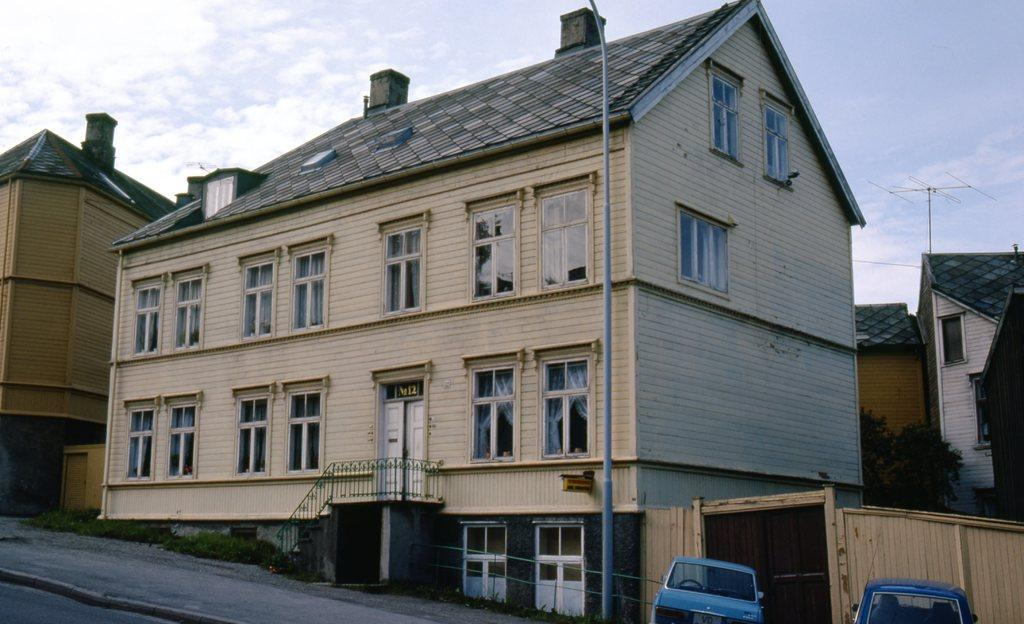What type of structures can be seen in the image? There are buildings in the image. What feature can be found on the buildings or nearby? Railings are present in the image. What type of vegetation is visible in the image? Shrubs and trees are present in the image. What mode of transportation can be seen on the road in the image? Motor vehicles are on the road in the image. What type of communication device is present in the image? There is an antenna in the image. What type of street furniture is visible in the image? A street pole is visible in the image. What type of signage is present in the image? A name board is present in the image. What is visible in the sky-wise in the image? The sky is visible in the image and has clouds. How many bottles are stacked on the street pole in the image? There are no bottles present on the street pole in the image. What time does the clock on the building show in the image? There are no clocks visible in the image. 